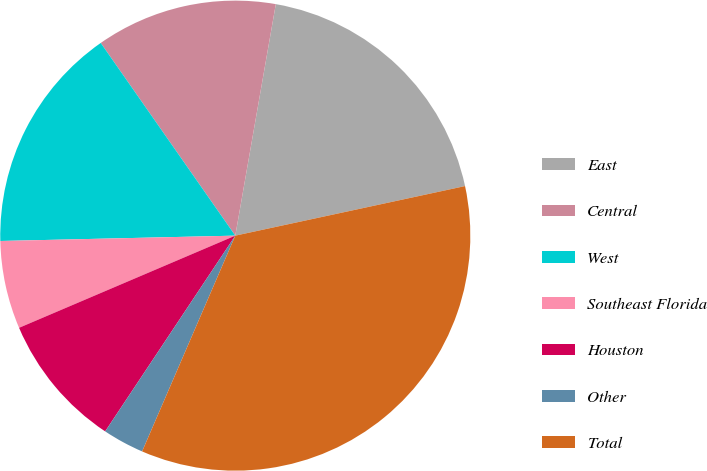Convert chart to OTSL. <chart><loc_0><loc_0><loc_500><loc_500><pie_chart><fcel>East<fcel>Central<fcel>West<fcel>Southeast Florida<fcel>Houston<fcel>Other<fcel>Total<nl><fcel>18.86%<fcel>12.46%<fcel>15.66%<fcel>6.05%<fcel>9.25%<fcel>2.85%<fcel>34.87%<nl></chart> 